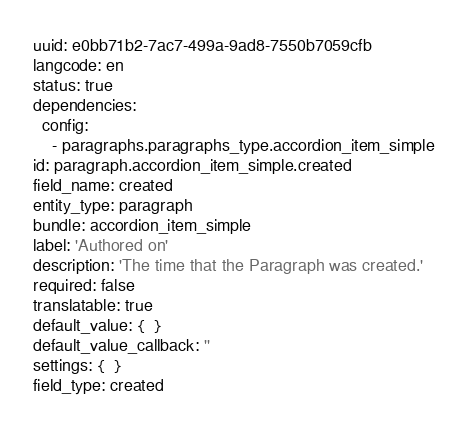Convert code to text. <code><loc_0><loc_0><loc_500><loc_500><_YAML_>uuid: e0bb71b2-7ac7-499a-9ad8-7550b7059cfb
langcode: en
status: true
dependencies:
  config:
    - paragraphs.paragraphs_type.accordion_item_simple
id: paragraph.accordion_item_simple.created
field_name: created
entity_type: paragraph
bundle: accordion_item_simple
label: 'Authored on'
description: 'The time that the Paragraph was created.'
required: false
translatable: true
default_value: {  }
default_value_callback: ''
settings: {  }
field_type: created
</code> 